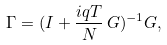<formula> <loc_0><loc_0><loc_500><loc_500>\Gamma = ( I + \frac { i q T } { N } \, G ) ^ { - 1 } G ,</formula> 